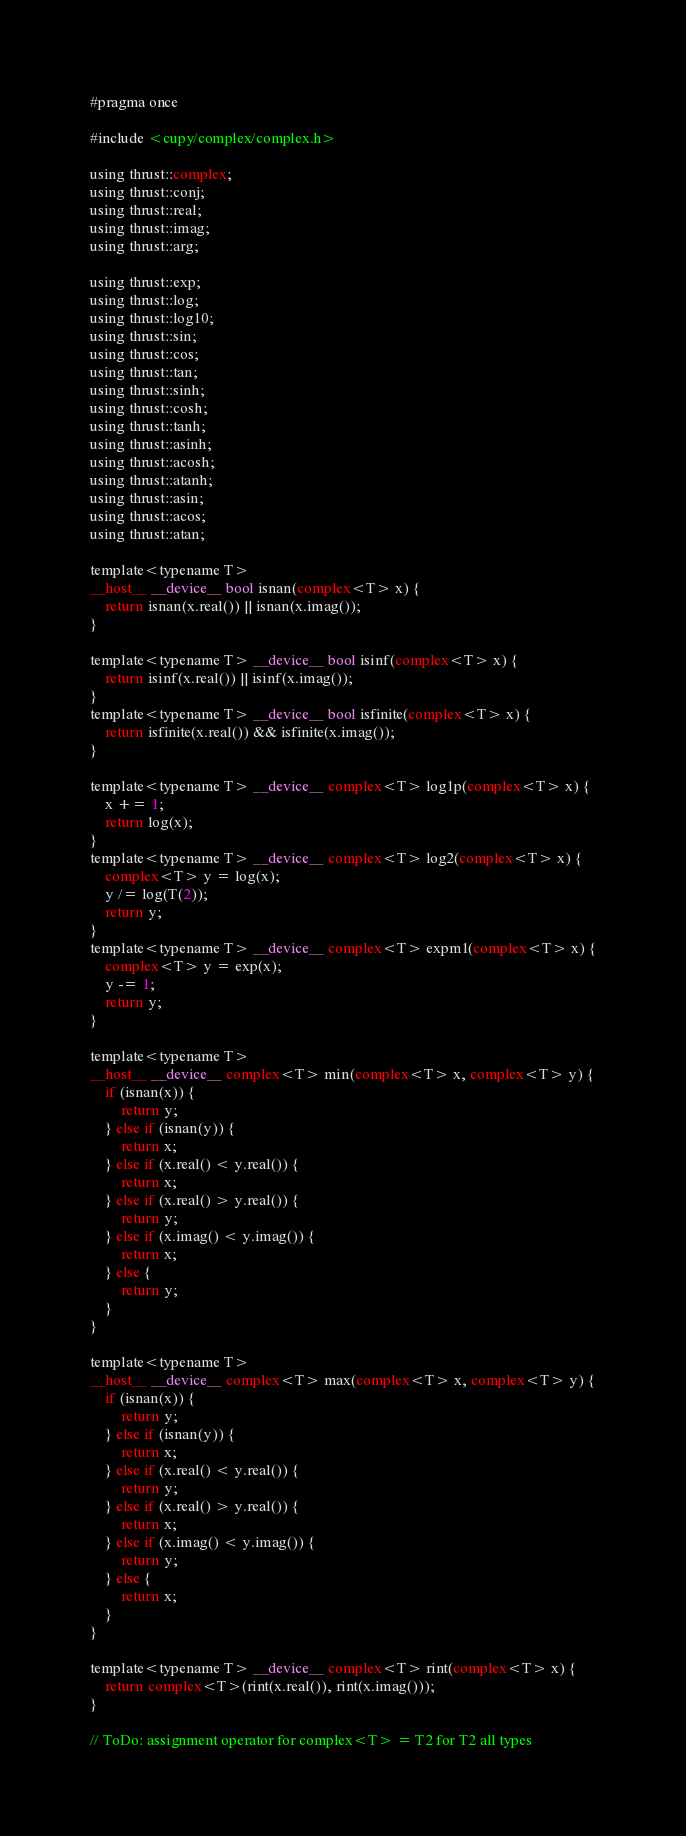Convert code to text. <code><loc_0><loc_0><loc_500><loc_500><_Cuda_>#pragma once

#include <cupy/complex/complex.h>

using thrust::complex;
using thrust::conj;
using thrust::real;
using thrust::imag;
using thrust::arg;

using thrust::exp;
using thrust::log;
using thrust::log10;
using thrust::sin;
using thrust::cos;
using thrust::tan;
using thrust::sinh;
using thrust::cosh;
using thrust::tanh;
using thrust::asinh;
using thrust::acosh;
using thrust::atanh;
using thrust::asin;
using thrust::acos;
using thrust::atan;

template<typename T>
__host__ __device__ bool isnan(complex<T> x) {
    return isnan(x.real()) || isnan(x.imag());
}

template<typename T> __device__ bool isinf(complex<T> x) {
    return isinf(x.real()) || isinf(x.imag());
}
template<typename T> __device__ bool isfinite(complex<T> x) {
    return isfinite(x.real()) && isfinite(x.imag());
}

template<typename T> __device__ complex<T> log1p(complex<T> x) {
    x += 1;
    return log(x);
}
template<typename T> __device__ complex<T> log2(complex<T> x) {
    complex<T> y = log(x);
    y /= log(T(2));
    return y;
}
template<typename T> __device__ complex<T> expm1(complex<T> x) {
    complex<T> y = exp(x);
    y -= 1;
    return y;
}

template<typename T>
__host__ __device__ complex<T> min(complex<T> x, complex<T> y) {
    if (isnan(x)) {
        return y;
    } else if (isnan(y)) {
        return x;
    } else if (x.real() < y.real()) {
        return x;
    } else if (x.real() > y.real()) {
        return y;
    } else if (x.imag() < y.imag()) {
        return x;
    } else {
        return y;
    }
}

template<typename T>
__host__ __device__ complex<T> max(complex<T> x, complex<T> y) {
    if (isnan(x)) {
        return y;
    } else if (isnan(y)) {
        return x;
    } else if (x.real() < y.real()) {
        return y;
    } else if (x.real() > y.real()) {
        return x;
    } else if (x.imag() < y.imag()) {
        return y;
    } else {
        return x;
    }
}

template<typename T> __device__ complex<T> rint(complex<T> x) {
    return complex<T>(rint(x.real()), rint(x.imag()));
}

// ToDo: assignment operator for complex<T> = T2 for T2 all types
</code> 